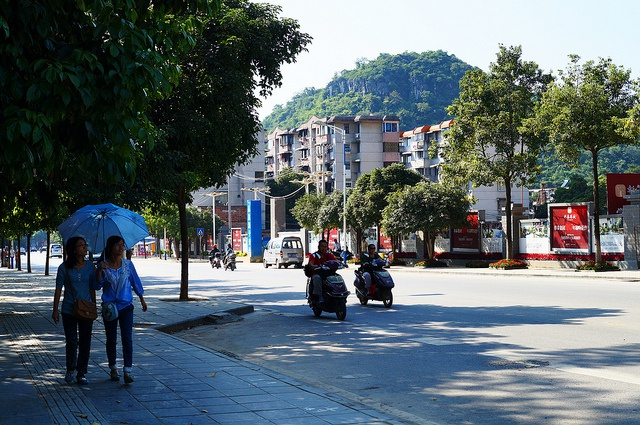Describe the objects in this image and their specific colors. I can see people in black, navy, blue, and gray tones, people in black, navy, blue, and darkblue tones, umbrella in black, navy, blue, darkblue, and gray tones, motorcycle in black, navy, blue, and gray tones, and truck in black, white, gray, and darkgray tones in this image. 